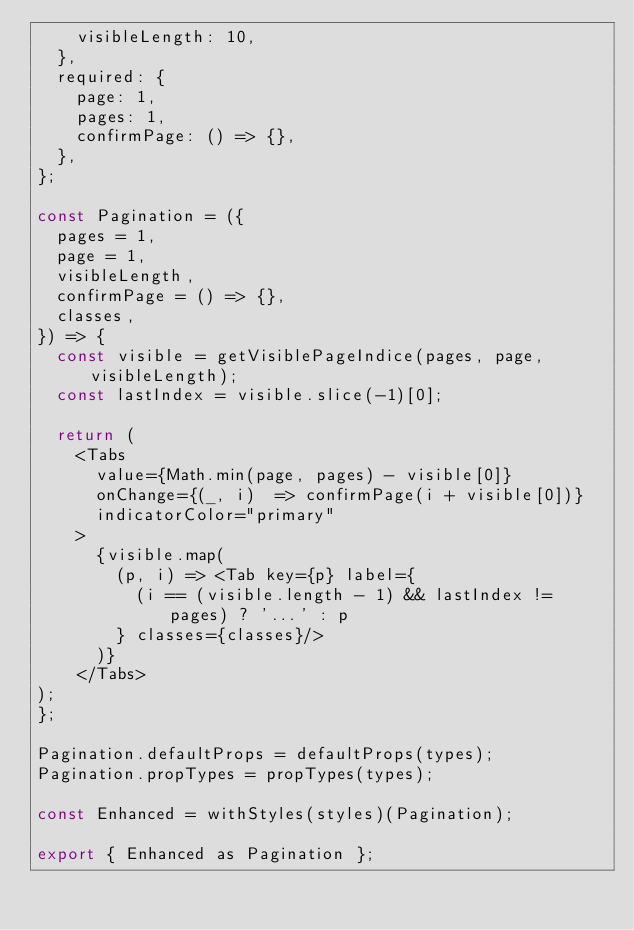<code> <loc_0><loc_0><loc_500><loc_500><_JavaScript_>    visibleLength: 10,
  },
  required: {
    page: 1,
    pages: 1,
    confirmPage: () => {},
  },
};

const Pagination = ({
  pages = 1,
  page = 1,
  visibleLength,
  confirmPage = () => {},
  classes,
}) => {
  const visible = getVisiblePageIndice(pages, page, visibleLength);
  const lastIndex = visible.slice(-1)[0];

  return (
    <Tabs
      value={Math.min(page, pages) - visible[0]}
      onChange={(_, i)  => confirmPage(i + visible[0])}
      indicatorColor="primary"
    >
      {visible.map(
        (p, i) => <Tab key={p} label={
          (i == (visible.length - 1) && lastIndex != pages) ? '...' : p
        } classes={classes}/>
      )}
    </Tabs>
);
};

Pagination.defaultProps = defaultProps(types);
Pagination.propTypes = propTypes(types);

const Enhanced = withStyles(styles)(Pagination);

export { Enhanced as Pagination };
</code> 